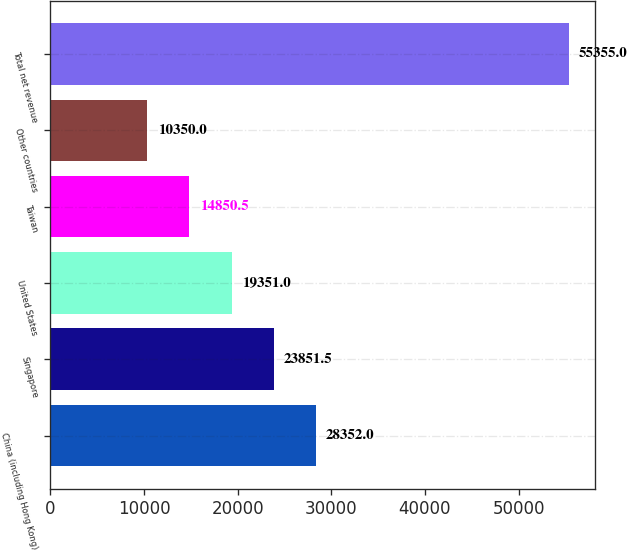Convert chart. <chart><loc_0><loc_0><loc_500><loc_500><bar_chart><fcel>China (including Hong Kong)<fcel>Singapore<fcel>United States<fcel>Taiwan<fcel>Other countries<fcel>Total net revenue<nl><fcel>28352<fcel>23851.5<fcel>19351<fcel>14850.5<fcel>10350<fcel>55355<nl></chart> 